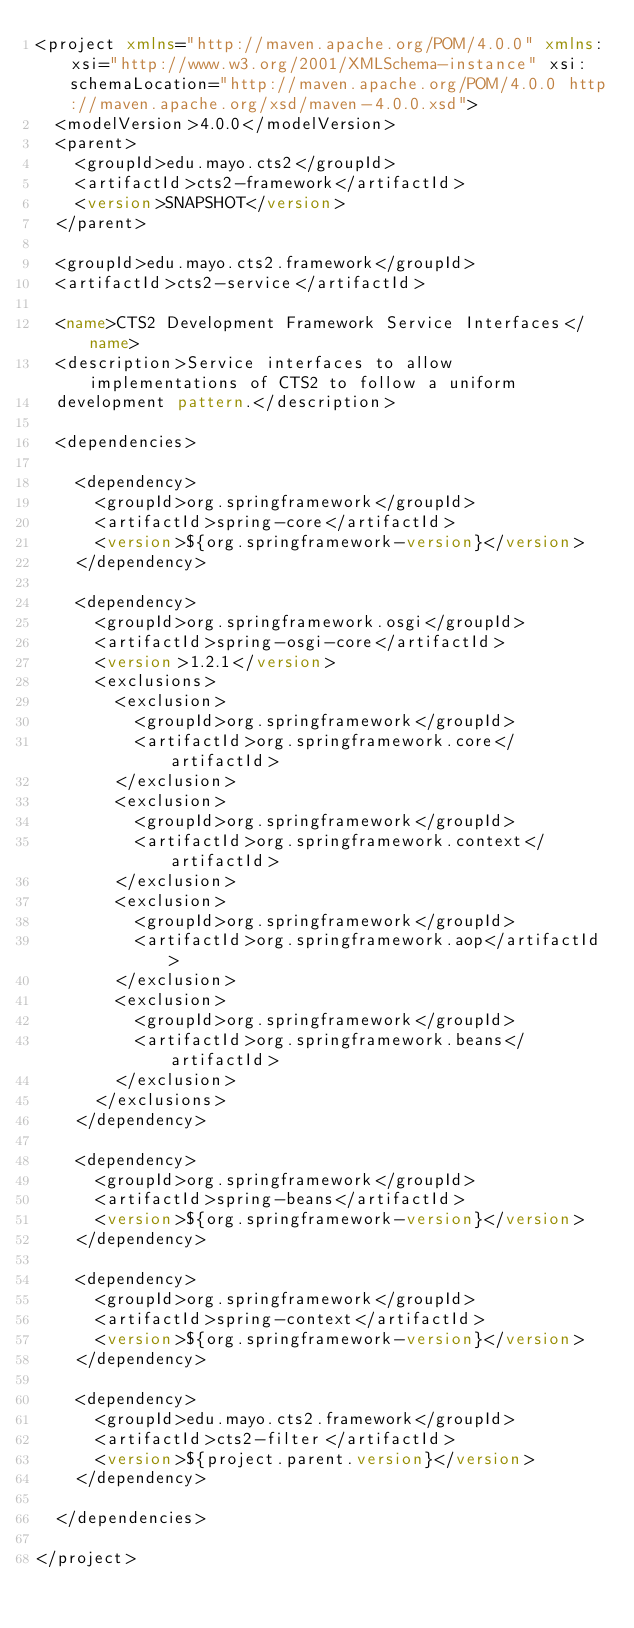<code> <loc_0><loc_0><loc_500><loc_500><_XML_><project xmlns="http://maven.apache.org/POM/4.0.0" xmlns:xsi="http://www.w3.org/2001/XMLSchema-instance" xsi:schemaLocation="http://maven.apache.org/POM/4.0.0 http://maven.apache.org/xsd/maven-4.0.0.xsd">
	<modelVersion>4.0.0</modelVersion>
	<parent>
		<groupId>edu.mayo.cts2</groupId>
		<artifactId>cts2-framework</artifactId>
		<version>SNAPSHOT</version>
	</parent>

	<groupId>edu.mayo.cts2.framework</groupId>
	<artifactId>cts2-service</artifactId>

	<name>CTS2 Development Framework Service Interfaces</name>
	<description>Service interfaces to allow implementations of CTS2 to follow a uniform
	development pattern.</description>

	<dependencies>

		<dependency>
			<groupId>org.springframework</groupId>
			<artifactId>spring-core</artifactId>
			<version>${org.springframework-version}</version>
		</dependency>

		<dependency>
			<groupId>org.springframework.osgi</groupId>
			<artifactId>spring-osgi-core</artifactId>
			<version>1.2.1</version>
			<exclusions>
				<exclusion>
					<groupId>org.springframework</groupId>
					<artifactId>org.springframework.core</artifactId>
				</exclusion>
				<exclusion>
					<groupId>org.springframework</groupId>
					<artifactId>org.springframework.context</artifactId>
				</exclusion>
				<exclusion>
					<groupId>org.springframework</groupId>
					<artifactId>org.springframework.aop</artifactId>
				</exclusion>
				<exclusion>
					<groupId>org.springframework</groupId>
					<artifactId>org.springframework.beans</artifactId>
				</exclusion>
			</exclusions>
		</dependency>

		<dependency>
			<groupId>org.springframework</groupId>
			<artifactId>spring-beans</artifactId>
			<version>${org.springframework-version}</version>
		</dependency>

		<dependency>
			<groupId>org.springframework</groupId>
			<artifactId>spring-context</artifactId>
			<version>${org.springframework-version}</version>
		</dependency>

		<dependency>
			<groupId>edu.mayo.cts2.framework</groupId>
			<artifactId>cts2-filter</artifactId>
			<version>${project.parent.version}</version>
		</dependency>

	</dependencies>

</project></code> 